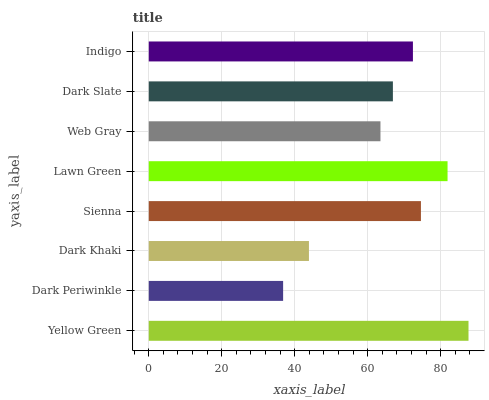Is Dark Periwinkle the minimum?
Answer yes or no. Yes. Is Yellow Green the maximum?
Answer yes or no. Yes. Is Dark Khaki the minimum?
Answer yes or no. No. Is Dark Khaki the maximum?
Answer yes or no. No. Is Dark Khaki greater than Dark Periwinkle?
Answer yes or no. Yes. Is Dark Periwinkle less than Dark Khaki?
Answer yes or no. Yes. Is Dark Periwinkle greater than Dark Khaki?
Answer yes or no. No. Is Dark Khaki less than Dark Periwinkle?
Answer yes or no. No. Is Indigo the high median?
Answer yes or no. Yes. Is Dark Slate the low median?
Answer yes or no. Yes. Is Web Gray the high median?
Answer yes or no. No. Is Dark Periwinkle the low median?
Answer yes or no. No. 